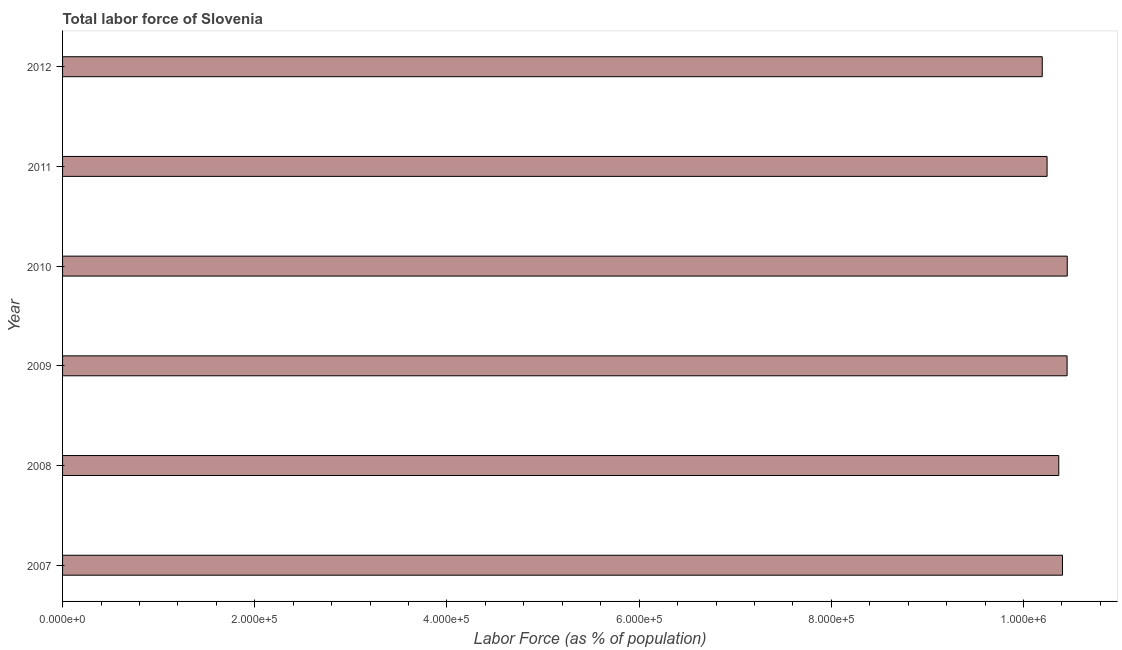What is the title of the graph?
Keep it short and to the point. Total labor force of Slovenia. What is the label or title of the X-axis?
Provide a short and direct response. Labor Force (as % of population). What is the total labor force in 2008?
Ensure brevity in your answer.  1.04e+06. Across all years, what is the maximum total labor force?
Provide a short and direct response. 1.05e+06. Across all years, what is the minimum total labor force?
Provide a short and direct response. 1.02e+06. What is the sum of the total labor force?
Offer a very short reply. 6.21e+06. What is the difference between the total labor force in 2007 and 2008?
Keep it short and to the point. 3852. What is the average total labor force per year?
Keep it short and to the point. 1.04e+06. What is the median total labor force?
Keep it short and to the point. 1.04e+06. In how many years, is the total labor force greater than 200000 %?
Provide a succinct answer. 6. Do a majority of the years between 2008 and 2009 (inclusive) have total labor force greater than 400000 %?
Offer a very short reply. Yes. What is the difference between the highest and the second highest total labor force?
Offer a very short reply. 167. Is the sum of the total labor force in 2007 and 2008 greater than the maximum total labor force across all years?
Give a very brief answer. Yes. What is the difference between the highest and the lowest total labor force?
Give a very brief answer. 2.60e+04. In how many years, is the total labor force greater than the average total labor force taken over all years?
Provide a succinct answer. 4. How many bars are there?
Give a very brief answer. 6. Are all the bars in the graph horizontal?
Make the answer very short. Yes. How many years are there in the graph?
Your answer should be very brief. 6. Are the values on the major ticks of X-axis written in scientific E-notation?
Provide a succinct answer. Yes. What is the Labor Force (as % of population) in 2007?
Offer a terse response. 1.04e+06. What is the Labor Force (as % of population) of 2008?
Your answer should be very brief. 1.04e+06. What is the Labor Force (as % of population) in 2009?
Offer a terse response. 1.05e+06. What is the Labor Force (as % of population) of 2010?
Give a very brief answer. 1.05e+06. What is the Labor Force (as % of population) in 2011?
Provide a succinct answer. 1.02e+06. What is the Labor Force (as % of population) in 2012?
Provide a succinct answer. 1.02e+06. What is the difference between the Labor Force (as % of population) in 2007 and 2008?
Your answer should be very brief. 3852. What is the difference between the Labor Force (as % of population) in 2007 and 2009?
Offer a terse response. -4800. What is the difference between the Labor Force (as % of population) in 2007 and 2010?
Provide a succinct answer. -4967. What is the difference between the Labor Force (as % of population) in 2007 and 2011?
Your answer should be compact. 1.60e+04. What is the difference between the Labor Force (as % of population) in 2007 and 2012?
Provide a succinct answer. 2.11e+04. What is the difference between the Labor Force (as % of population) in 2008 and 2009?
Your answer should be compact. -8652. What is the difference between the Labor Force (as % of population) in 2008 and 2010?
Your response must be concise. -8819. What is the difference between the Labor Force (as % of population) in 2008 and 2011?
Provide a short and direct response. 1.22e+04. What is the difference between the Labor Force (as % of population) in 2008 and 2012?
Your response must be concise. 1.72e+04. What is the difference between the Labor Force (as % of population) in 2009 and 2010?
Ensure brevity in your answer.  -167. What is the difference between the Labor Force (as % of population) in 2009 and 2011?
Provide a succinct answer. 2.08e+04. What is the difference between the Labor Force (as % of population) in 2009 and 2012?
Ensure brevity in your answer.  2.59e+04. What is the difference between the Labor Force (as % of population) in 2010 and 2011?
Give a very brief answer. 2.10e+04. What is the difference between the Labor Force (as % of population) in 2010 and 2012?
Ensure brevity in your answer.  2.60e+04. What is the difference between the Labor Force (as % of population) in 2011 and 2012?
Give a very brief answer. 5018. What is the ratio of the Labor Force (as % of population) in 2007 to that in 2009?
Your response must be concise. 0.99. What is the ratio of the Labor Force (as % of population) in 2007 to that in 2012?
Provide a succinct answer. 1.02. What is the ratio of the Labor Force (as % of population) in 2008 to that in 2009?
Keep it short and to the point. 0.99. What is the ratio of the Labor Force (as % of population) in 2008 to that in 2010?
Your answer should be compact. 0.99. What is the ratio of the Labor Force (as % of population) in 2008 to that in 2012?
Ensure brevity in your answer.  1.02. What is the ratio of the Labor Force (as % of population) in 2009 to that in 2012?
Provide a succinct answer. 1.02. What is the ratio of the Labor Force (as % of population) in 2010 to that in 2012?
Offer a terse response. 1.03. 